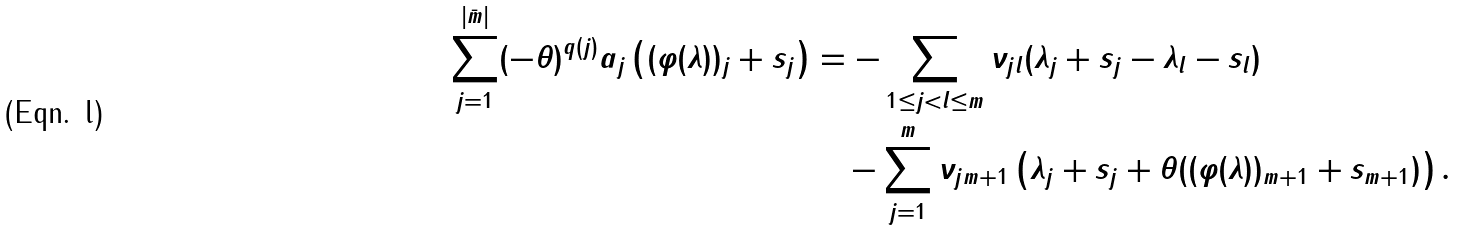Convert formula to latex. <formula><loc_0><loc_0><loc_500><loc_500>\sum _ { j = 1 } ^ { | \bar { m } | } ( - \theta ) ^ { q ( j ) } a _ { j } \left ( ( \varphi ( \lambda ) ) _ { j } + s _ { j } \right ) & = - \sum _ { 1 \leq j < l \leq m } \nu _ { j l } ( \lambda _ { j } + s _ { j } - \lambda _ { l } - s _ { l } ) \\ & \quad - \sum _ { j = 1 } ^ { m } \nu _ { j m + 1 } \left ( \lambda _ { j } + s _ { j } + \theta ( ( \varphi ( \lambda ) ) _ { m + 1 } + s _ { m + 1 } ) \right ) .</formula> 